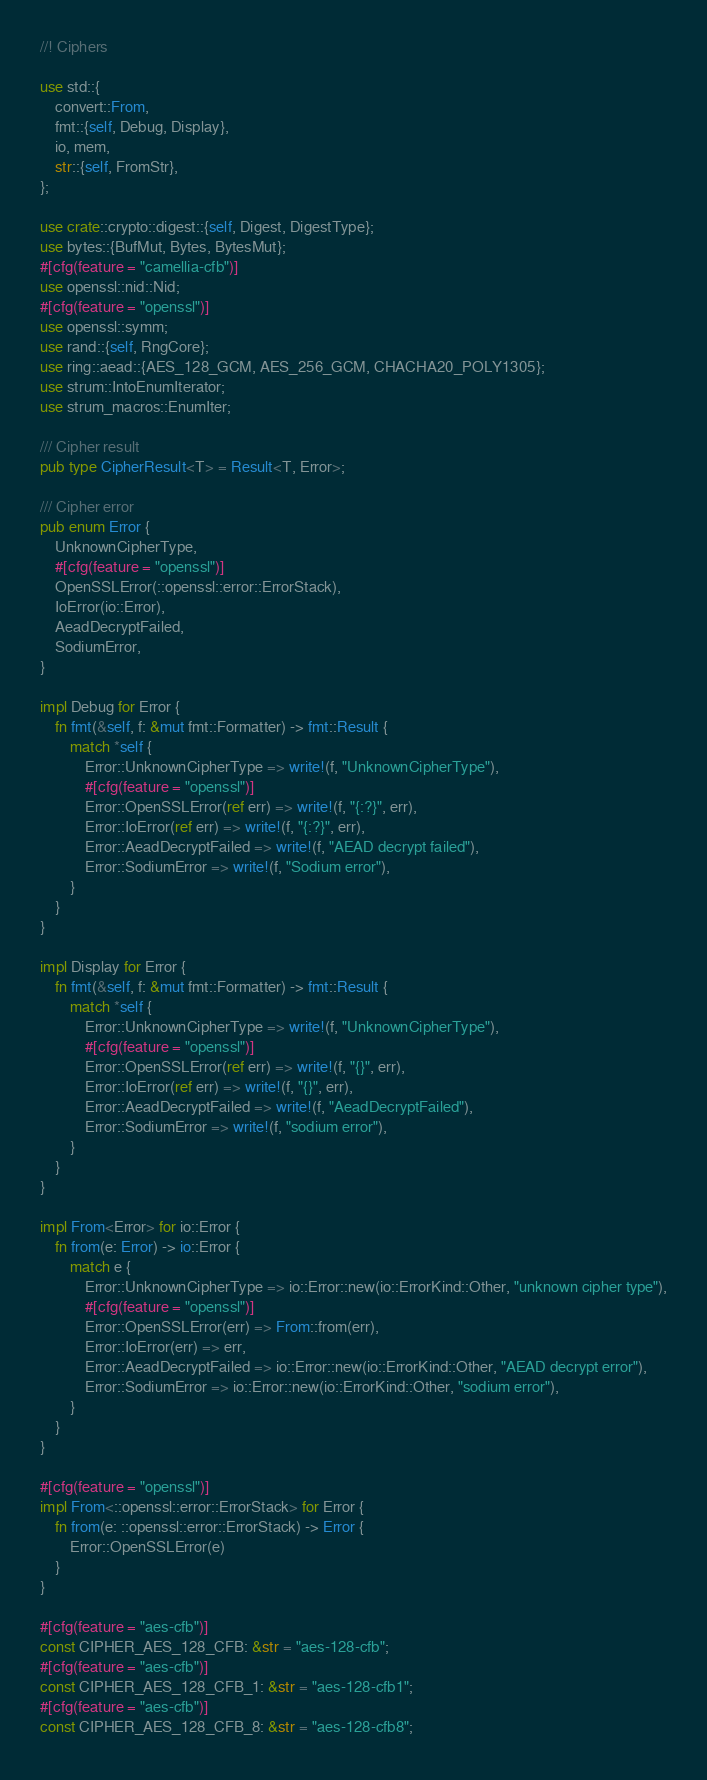Convert code to text. <code><loc_0><loc_0><loc_500><loc_500><_Rust_>//! Ciphers

use std::{
    convert::From,
    fmt::{self, Debug, Display},
    io, mem,
    str::{self, FromStr},
};

use crate::crypto::digest::{self, Digest, DigestType};
use bytes::{BufMut, Bytes, BytesMut};
#[cfg(feature = "camellia-cfb")]
use openssl::nid::Nid;
#[cfg(feature = "openssl")]
use openssl::symm;
use rand::{self, RngCore};
use ring::aead::{AES_128_GCM, AES_256_GCM, CHACHA20_POLY1305};
use strum::IntoEnumIterator;
use strum_macros::EnumIter;

/// Cipher result
pub type CipherResult<T> = Result<T, Error>;

/// Cipher error
pub enum Error {
    UnknownCipherType,
    #[cfg(feature = "openssl")]
    OpenSSLError(::openssl::error::ErrorStack),
    IoError(io::Error),
    AeadDecryptFailed,
    SodiumError,
}

impl Debug for Error {
    fn fmt(&self, f: &mut fmt::Formatter) -> fmt::Result {
        match *self {
            Error::UnknownCipherType => write!(f, "UnknownCipherType"),
            #[cfg(feature = "openssl")]
            Error::OpenSSLError(ref err) => write!(f, "{:?}", err),
            Error::IoError(ref err) => write!(f, "{:?}", err),
            Error::AeadDecryptFailed => write!(f, "AEAD decrypt failed"),
            Error::SodiumError => write!(f, "Sodium error"),
        }
    }
}

impl Display for Error {
    fn fmt(&self, f: &mut fmt::Formatter) -> fmt::Result {
        match *self {
            Error::UnknownCipherType => write!(f, "UnknownCipherType"),
            #[cfg(feature = "openssl")]
            Error::OpenSSLError(ref err) => write!(f, "{}", err),
            Error::IoError(ref err) => write!(f, "{}", err),
            Error::AeadDecryptFailed => write!(f, "AeadDecryptFailed"),
            Error::SodiumError => write!(f, "sodium error"),
        }
    }
}

impl From<Error> for io::Error {
    fn from(e: Error) -> io::Error {
        match e {
            Error::UnknownCipherType => io::Error::new(io::ErrorKind::Other, "unknown cipher type"),
            #[cfg(feature = "openssl")]
            Error::OpenSSLError(err) => From::from(err),
            Error::IoError(err) => err,
            Error::AeadDecryptFailed => io::Error::new(io::ErrorKind::Other, "AEAD decrypt error"),
            Error::SodiumError => io::Error::new(io::ErrorKind::Other, "sodium error"),
        }
    }
}

#[cfg(feature = "openssl")]
impl From<::openssl::error::ErrorStack> for Error {
    fn from(e: ::openssl::error::ErrorStack) -> Error {
        Error::OpenSSLError(e)
    }
}

#[cfg(feature = "aes-cfb")]
const CIPHER_AES_128_CFB: &str = "aes-128-cfb";
#[cfg(feature = "aes-cfb")]
const CIPHER_AES_128_CFB_1: &str = "aes-128-cfb1";
#[cfg(feature = "aes-cfb")]
const CIPHER_AES_128_CFB_8: &str = "aes-128-cfb8";</code> 